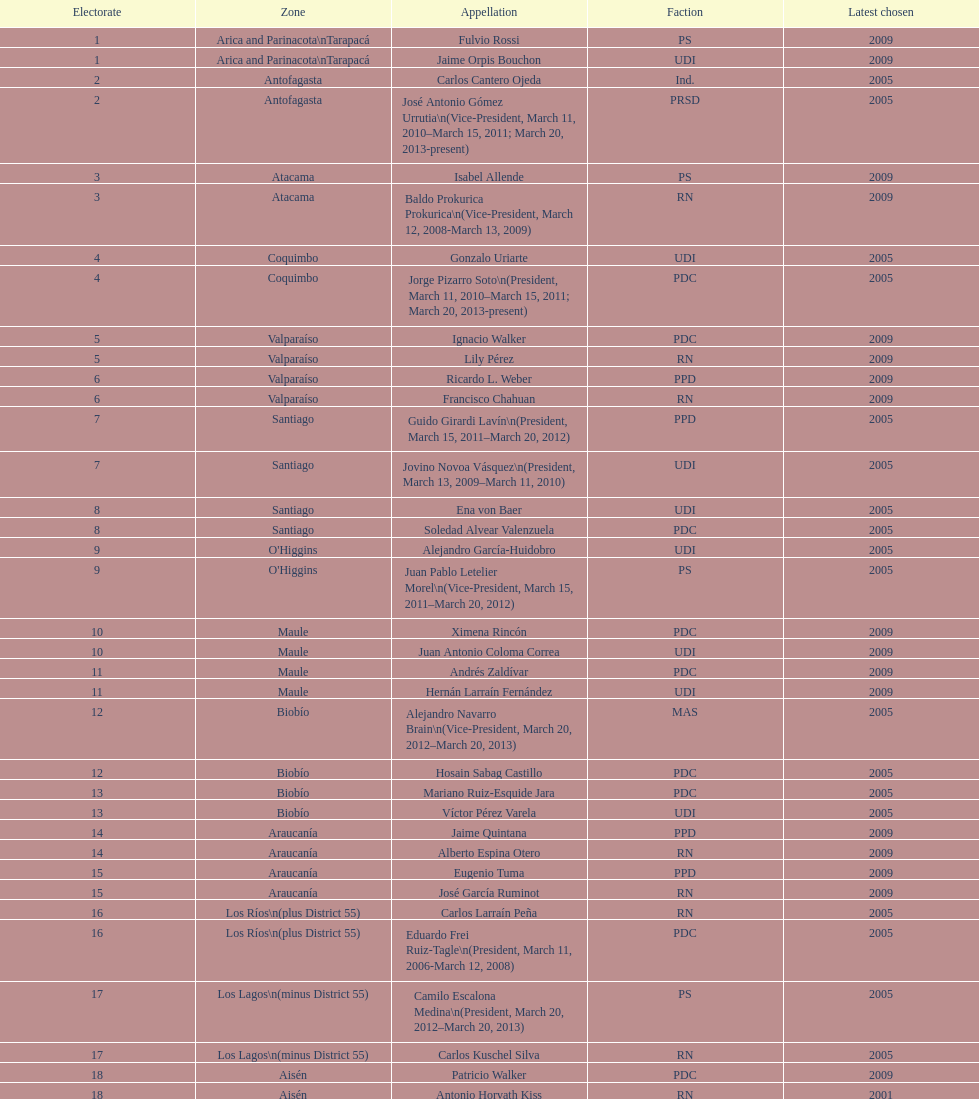What is the first name on the table? Fulvio Rossi. 